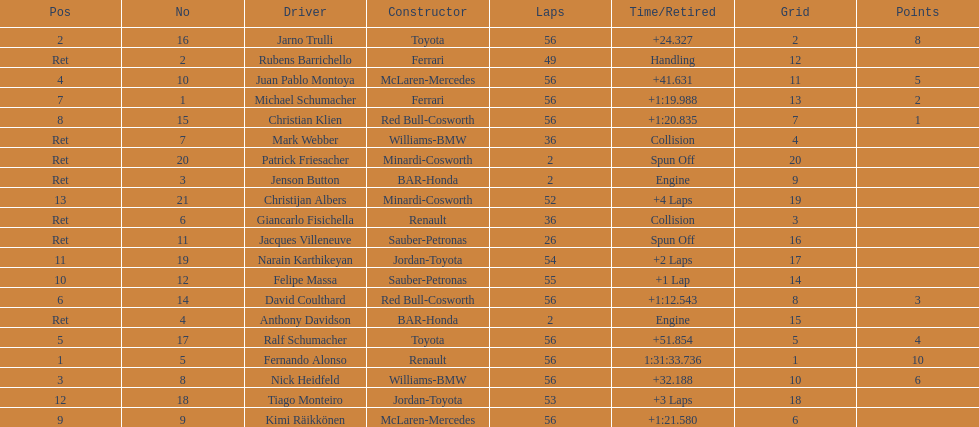How long did it take fernando alonso to finish the race? 1:31:33.736. 